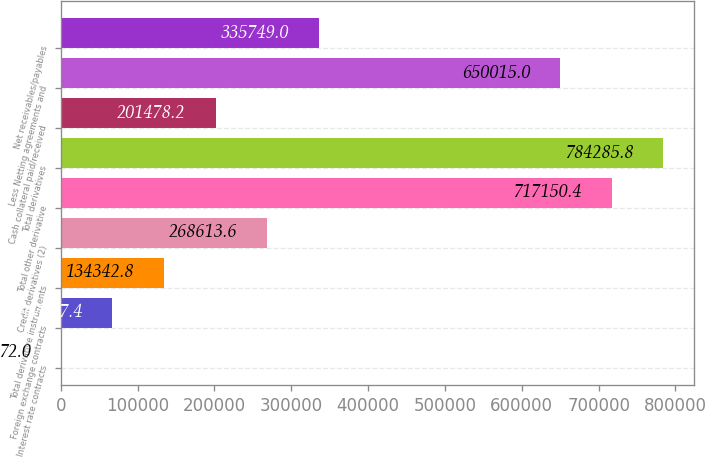<chart> <loc_0><loc_0><loc_500><loc_500><bar_chart><fcel>Interest rate contracts<fcel>Foreign exchange contracts<fcel>Total derivative instruments<fcel>Credit derivatives (2)<fcel>Total other derivative<fcel>Total derivatives<fcel>Cash collateral paid/received<fcel>Less Netting agreements and<fcel>Net receivables/payables<nl><fcel>72<fcel>67207.4<fcel>134343<fcel>268614<fcel>717150<fcel>784286<fcel>201478<fcel>650015<fcel>335749<nl></chart> 